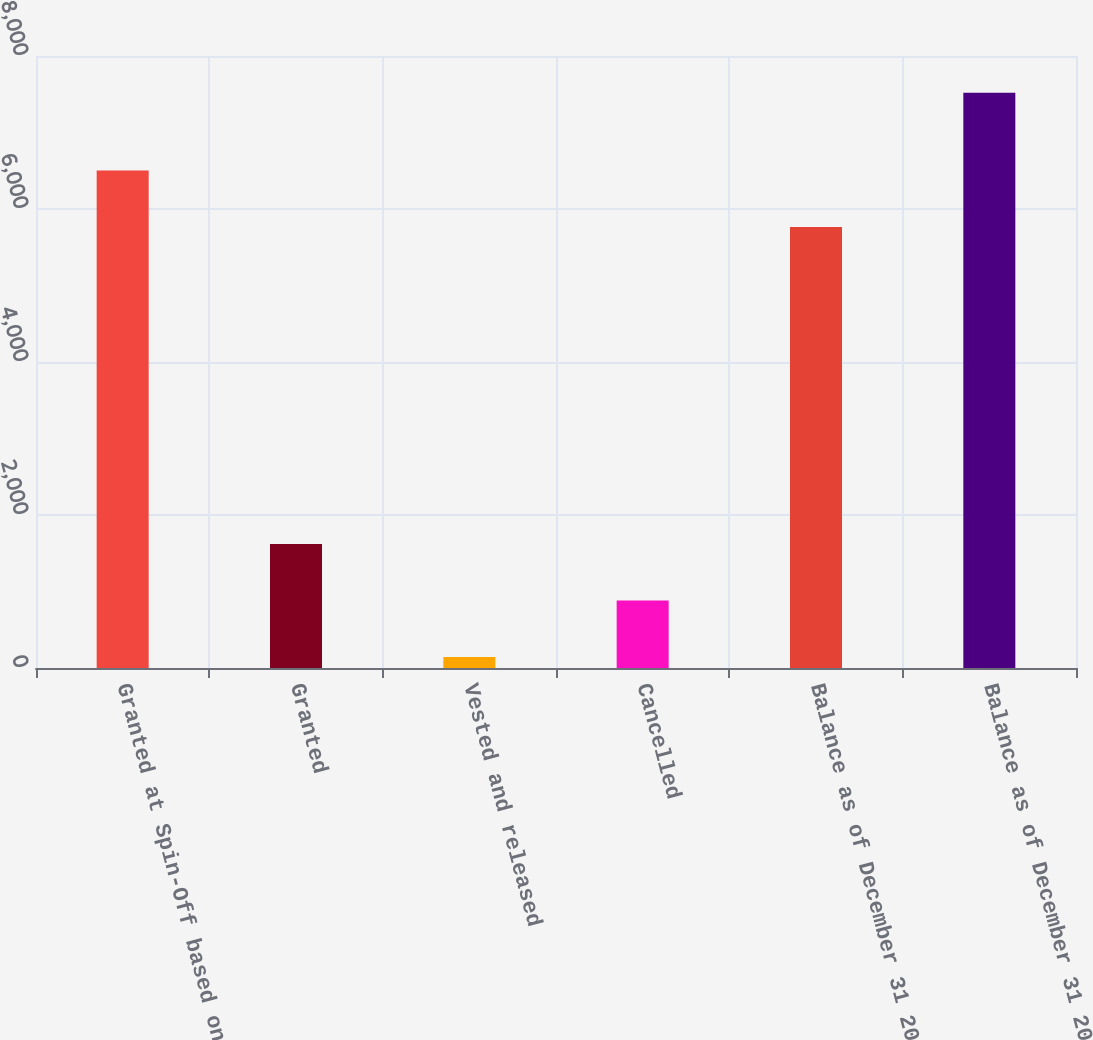Convert chart to OTSL. <chart><loc_0><loc_0><loc_500><loc_500><bar_chart><fcel>Granted at Spin-Off based on<fcel>Granted<fcel>Vested and released<fcel>Cancelled<fcel>Balance as of December 31 2005<fcel>Balance as of December 31 2006<nl><fcel>6502.7<fcel>1619.4<fcel>144<fcel>881.7<fcel>5765<fcel>7521<nl></chart> 